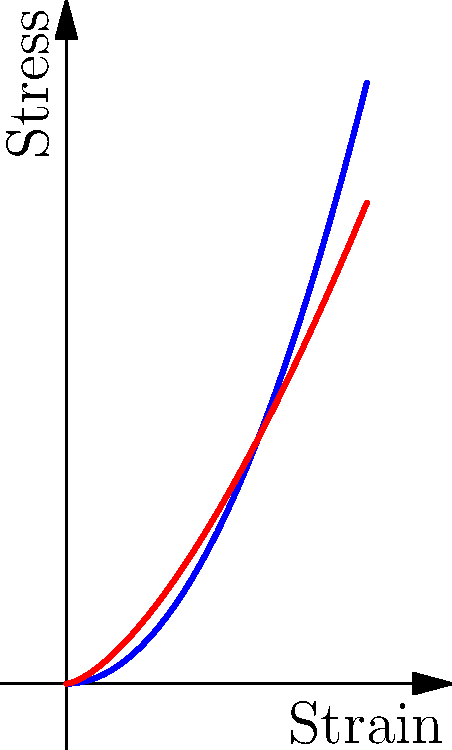The graph shows stress-strain curves for normal skin and aged skin. Based on the curves, which of the following statements is true about the elastic properties of aged skin compared to normal skin?

A) Aged skin has higher elasticity
B) Aged skin has lower elasticity
C) Aged skin and normal skin have the same elasticity
D) The elasticity difference cannot be determined from this graph To answer this question, we need to analyze the stress-strain curves and understand what they represent:

1. The stress-strain curve shows the relationship between the applied force (stress) and the resulting deformation (strain) of a material.

2. The slope of the curve represents the material's stiffness or elastic modulus. A steeper slope indicates higher stiffness and lower elasticity.

3. Comparing the two curves:
   - The blue curve (normal skin) is a quadratic function: $f(x) = 0.5x^2$
   - The red curve (aged skin) is a power function: $g(x) = 0.8x^{1.5}$

4. For small strains (near the origin), the red curve (aged skin) has a steeper slope than the blue curve (normal skin).

5. As strain increases, the difference in slope becomes more pronounced, with the aged skin curve consistently steeper than the normal skin curve.

6. A steeper slope indicates that more stress is required to produce the same amount of strain, which means the material is less elastic (or more stiff).

Therefore, based on the stress-strain curves provided, aged skin demonstrates lower elasticity compared to normal skin.
Answer: B) Aged skin has lower elasticity 